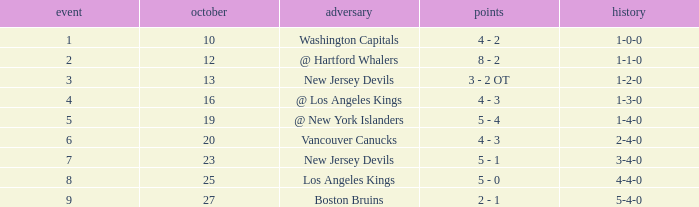Which game has the highest score in October with 9? 27.0. Can you parse all the data within this table? {'header': ['event', 'october', 'adversary', 'points', 'history'], 'rows': [['1', '10', 'Washington Capitals', '4 - 2', '1-0-0'], ['2', '12', '@ Hartford Whalers', '8 - 2', '1-1-0'], ['3', '13', 'New Jersey Devils', '3 - 2 OT', '1-2-0'], ['4', '16', '@ Los Angeles Kings', '4 - 3', '1-3-0'], ['5', '19', '@ New York Islanders', '5 - 4', '1-4-0'], ['6', '20', 'Vancouver Canucks', '4 - 3', '2-4-0'], ['7', '23', 'New Jersey Devils', '5 - 1', '3-4-0'], ['8', '25', 'Los Angeles Kings', '5 - 0', '4-4-0'], ['9', '27', 'Boston Bruins', '2 - 1', '5-4-0']]} 